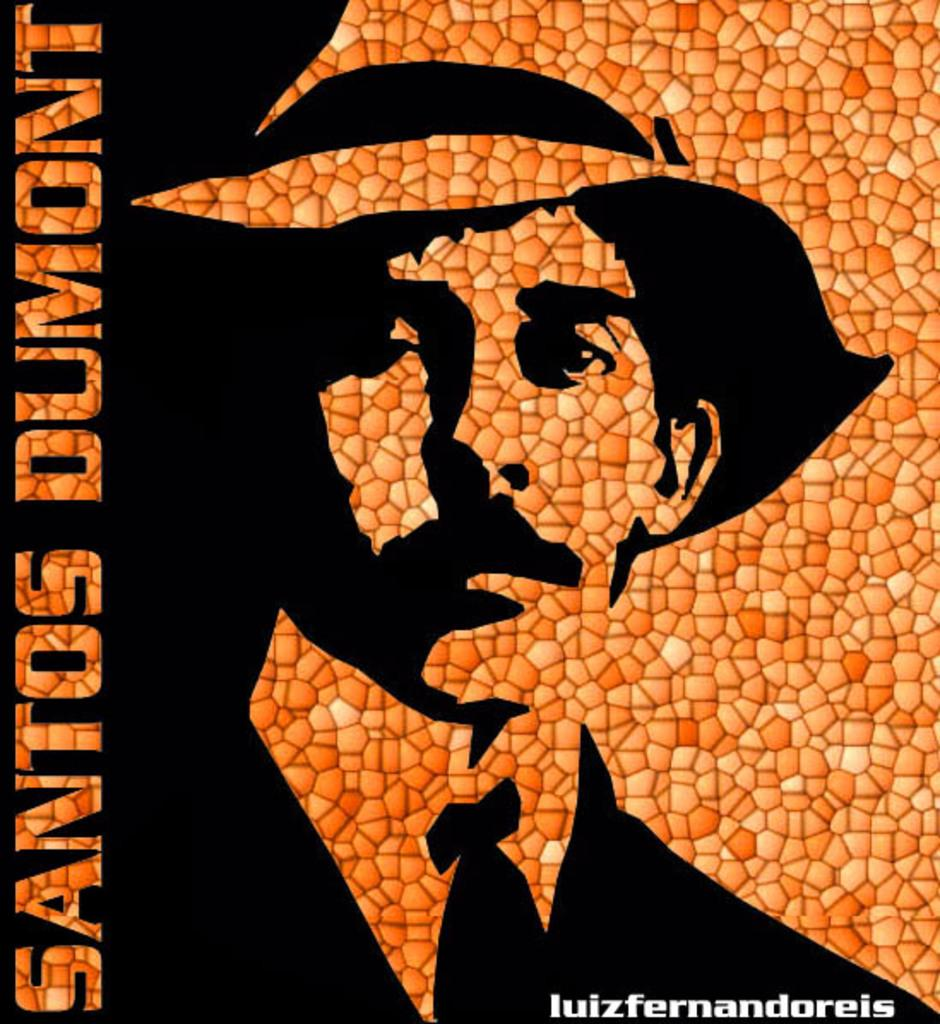<image>
Summarize the visual content of the image. A black and orange sign for Santos Dumont and Luiz Fernandoreis. 